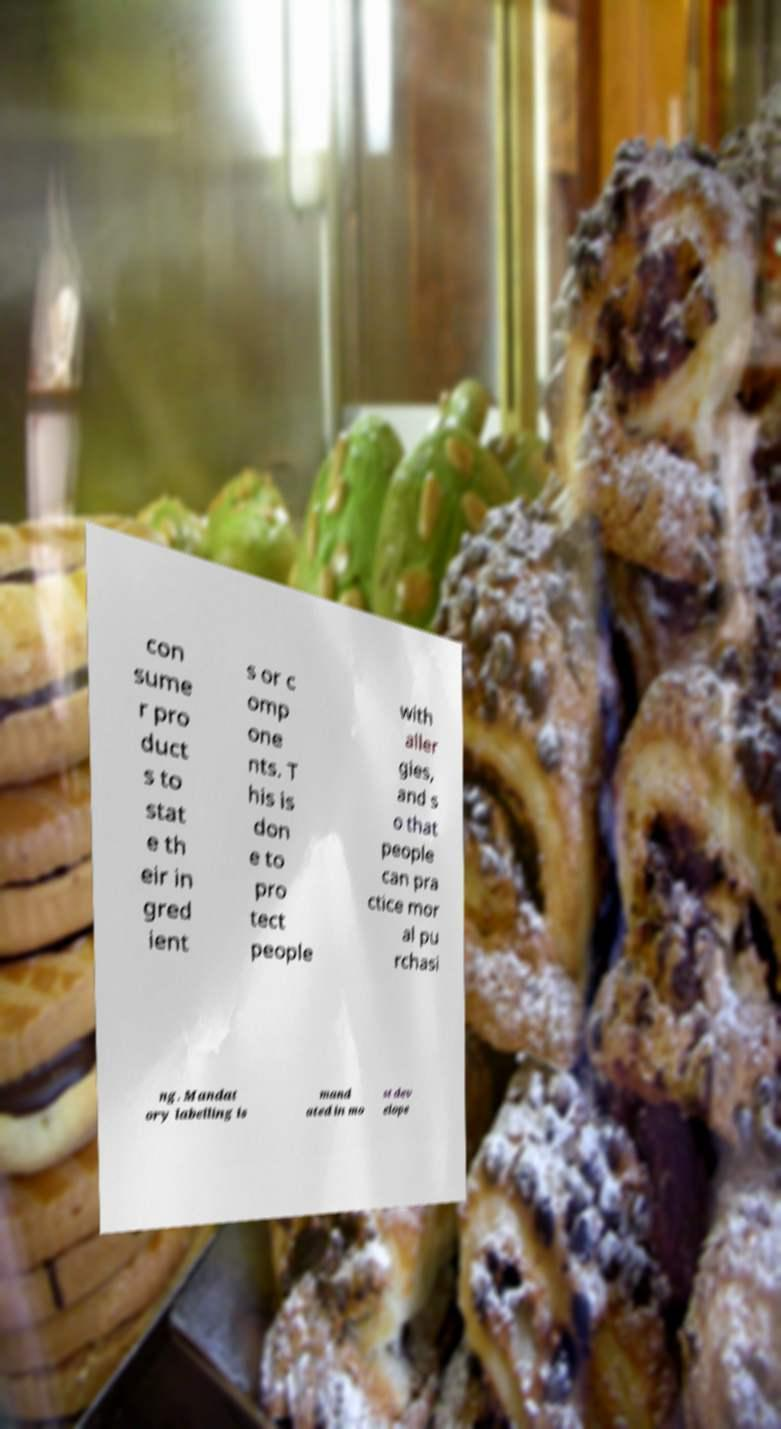Can you read and provide the text displayed in the image?This photo seems to have some interesting text. Can you extract and type it out for me? con sume r pro duct s to stat e th eir in gred ient s or c omp one nts. T his is don e to pro tect people with aller gies, and s o that people can pra ctice mor al pu rchasi ng. Mandat ory labelling is mand ated in mo st dev elope 